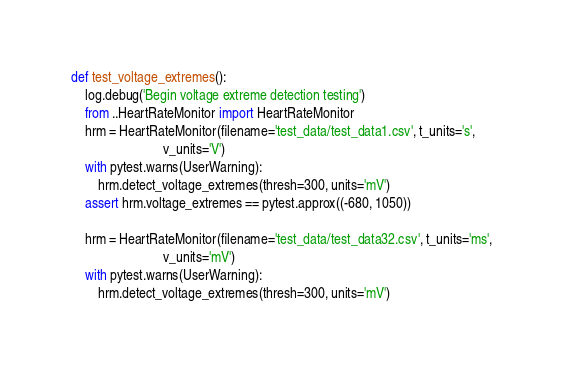<code> <loc_0><loc_0><loc_500><loc_500><_Python_>
def test_voltage_extremes():
    log.debug('Begin voltage extreme detection testing')
    from ..HeartRateMonitor import HeartRateMonitor
    hrm = HeartRateMonitor(filename='test_data/test_data1.csv', t_units='s',
                           v_units='V')
    with pytest.warns(UserWarning):
        hrm.detect_voltage_extremes(thresh=300, units='mV')
    assert hrm.voltage_extremes == pytest.approx((-680, 1050))

    hrm = HeartRateMonitor(filename='test_data/test_data32.csv', t_units='ms',
                           v_units='mV')
    with pytest.warns(UserWarning):
        hrm.detect_voltage_extremes(thresh=300, units='mV')
</code> 